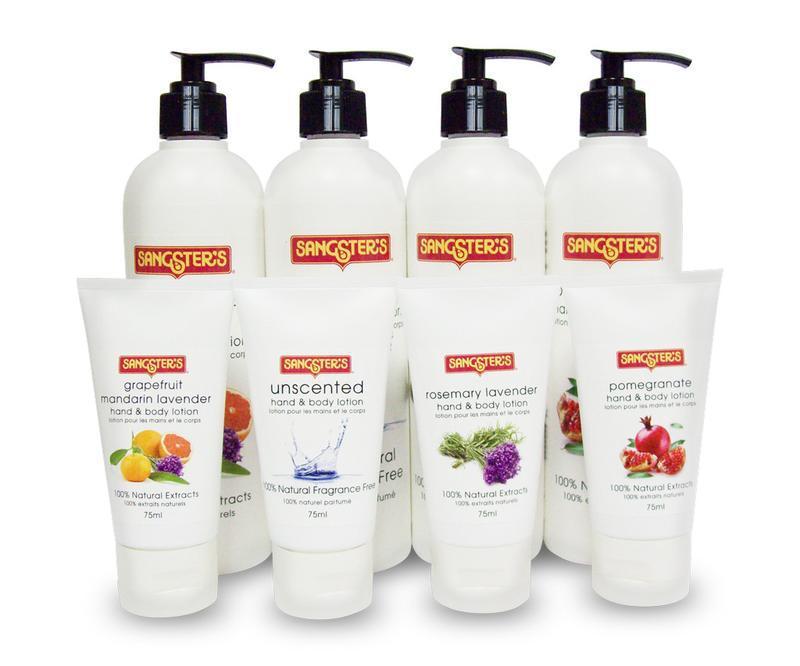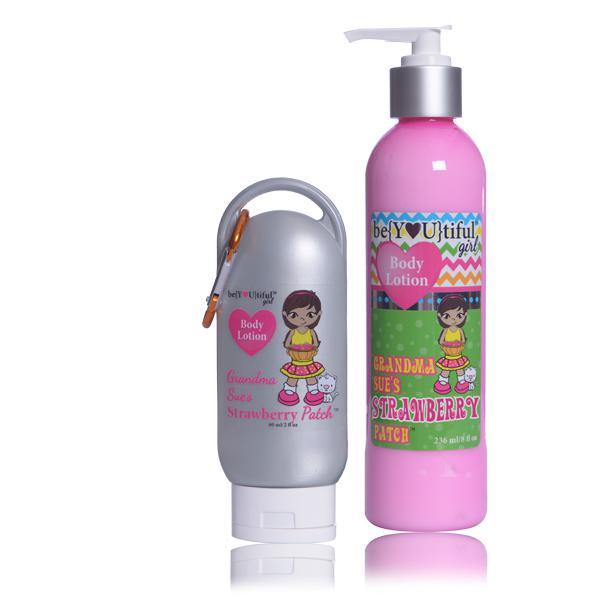The first image is the image on the left, the second image is the image on the right. Given the left and right images, does the statement "One image includes an upright bottle with a black pump-top near a tube displayed upright sitting on its white cap." hold true? Answer yes or no. Yes. The first image is the image on the left, the second image is the image on the right. Examine the images to the left and right. Is the description "There are more items in the right image than in the left image." accurate? Answer yes or no. No. 